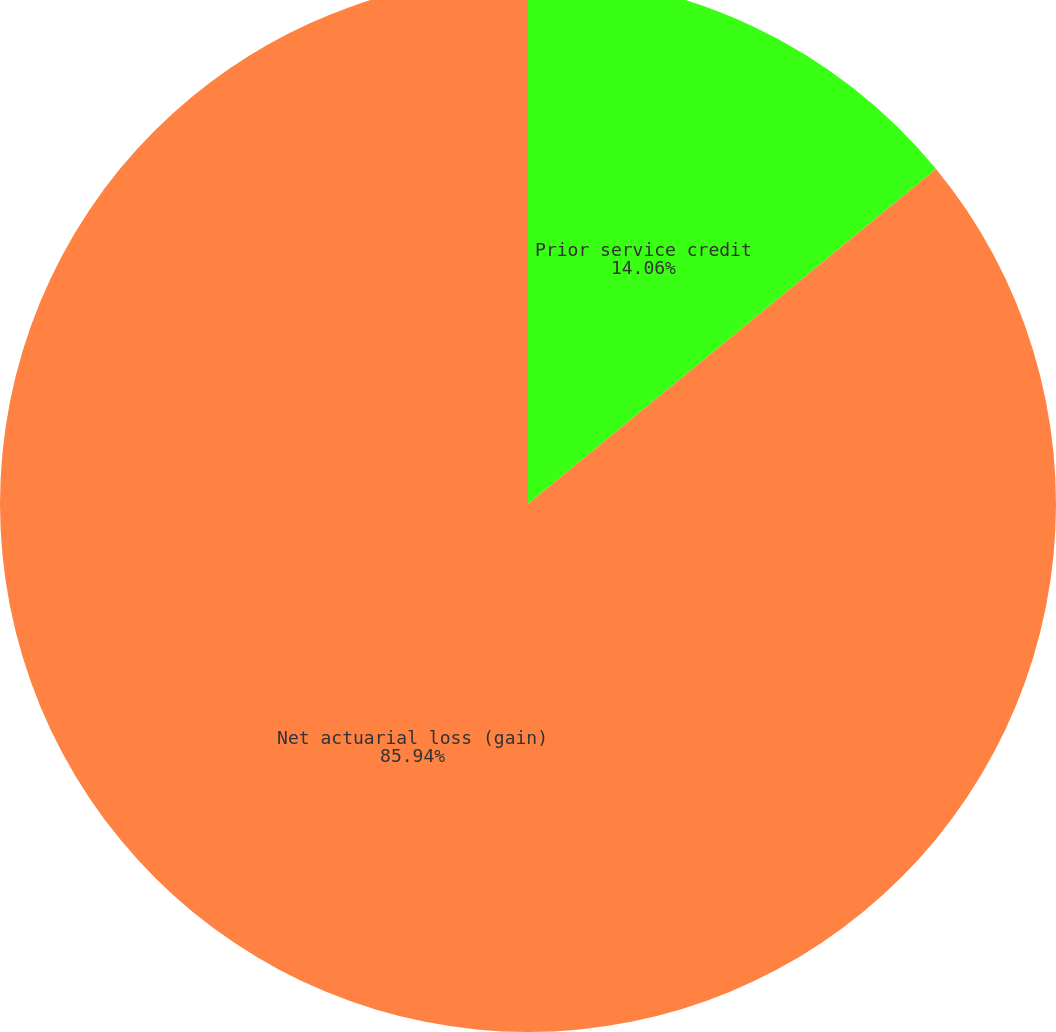Convert chart. <chart><loc_0><loc_0><loc_500><loc_500><pie_chart><fcel>Prior service credit<fcel>Net actuarial loss (gain)<nl><fcel>14.06%<fcel>85.94%<nl></chart> 